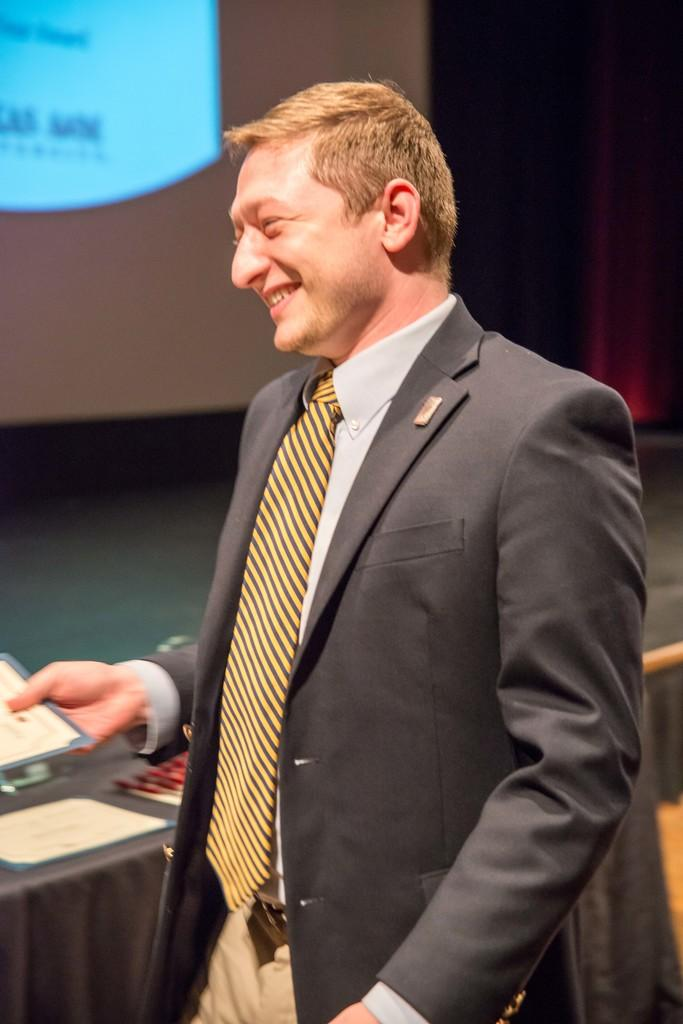What is the main subject of the image? The main subject of the image is a man. What is the man wearing? The man is wearing a black suit. What is the man doing in the image? The man is standing and smiling. What can be seen in the background of the image? There is a projector screen in the background of the image. What type of meat is the man holding in the image? There is no meat present in the image; the man is not holding anything. 